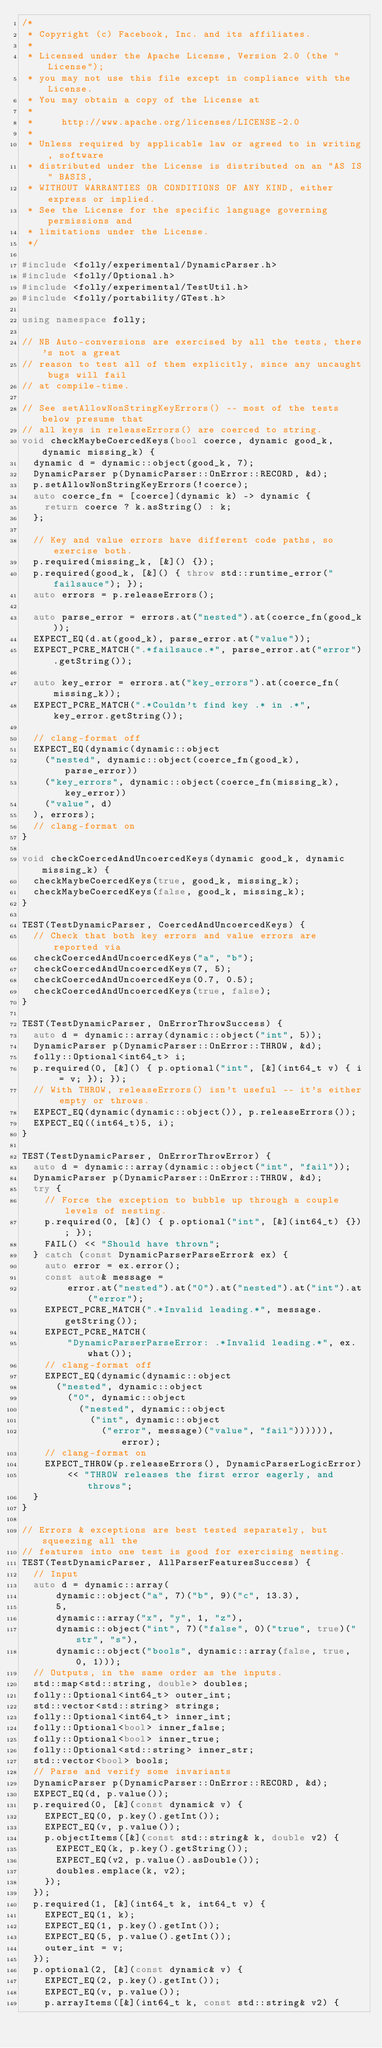<code> <loc_0><loc_0><loc_500><loc_500><_C++_>/*
 * Copyright (c) Facebook, Inc. and its affiliates.
 *
 * Licensed under the Apache License, Version 2.0 (the "License");
 * you may not use this file except in compliance with the License.
 * You may obtain a copy of the License at
 *
 *     http://www.apache.org/licenses/LICENSE-2.0
 *
 * Unless required by applicable law or agreed to in writing, software
 * distributed under the License is distributed on an "AS IS" BASIS,
 * WITHOUT WARRANTIES OR CONDITIONS OF ANY KIND, either express or implied.
 * See the License for the specific language governing permissions and
 * limitations under the License.
 */

#include <folly/experimental/DynamicParser.h>
#include <folly/Optional.h>
#include <folly/experimental/TestUtil.h>
#include <folly/portability/GTest.h>

using namespace folly;

// NB Auto-conversions are exercised by all the tests, there's not a great
// reason to test all of them explicitly, since any uncaught bugs will fail
// at compile-time.

// See setAllowNonStringKeyErrors() -- most of the tests below presume that
// all keys in releaseErrors() are coerced to string.
void checkMaybeCoercedKeys(bool coerce, dynamic good_k, dynamic missing_k) {
  dynamic d = dynamic::object(good_k, 7);
  DynamicParser p(DynamicParser::OnError::RECORD, &d);
  p.setAllowNonStringKeyErrors(!coerce);
  auto coerce_fn = [coerce](dynamic k) -> dynamic {
    return coerce ? k.asString() : k;
  };

  // Key and value errors have different code paths, so exercise both.
  p.required(missing_k, [&]() {});
  p.required(good_k, [&]() { throw std::runtime_error("failsauce"); });
  auto errors = p.releaseErrors();

  auto parse_error = errors.at("nested").at(coerce_fn(good_k));
  EXPECT_EQ(d.at(good_k), parse_error.at("value"));
  EXPECT_PCRE_MATCH(".*failsauce.*", parse_error.at("error").getString());

  auto key_error = errors.at("key_errors").at(coerce_fn(missing_k));
  EXPECT_PCRE_MATCH(".*Couldn't find key .* in .*", key_error.getString());

  // clang-format off
  EXPECT_EQ(dynamic(dynamic::object
    ("nested", dynamic::object(coerce_fn(good_k), parse_error))
    ("key_errors", dynamic::object(coerce_fn(missing_k), key_error))
    ("value", d)
  ), errors);
  // clang-format on
}

void checkCoercedAndUncoercedKeys(dynamic good_k, dynamic missing_k) {
  checkMaybeCoercedKeys(true, good_k, missing_k);
  checkMaybeCoercedKeys(false, good_k, missing_k);
}

TEST(TestDynamicParser, CoercedAndUncoercedKeys) {
  // Check that both key errors and value errors are reported via
  checkCoercedAndUncoercedKeys("a", "b");
  checkCoercedAndUncoercedKeys(7, 5);
  checkCoercedAndUncoercedKeys(0.7, 0.5);
  checkCoercedAndUncoercedKeys(true, false);
}

TEST(TestDynamicParser, OnErrorThrowSuccess) {
  auto d = dynamic::array(dynamic::object("int", 5));
  DynamicParser p(DynamicParser::OnError::THROW, &d);
  folly::Optional<int64_t> i;
  p.required(0, [&]() { p.optional("int", [&](int64_t v) { i = v; }); });
  // With THROW, releaseErrors() isn't useful -- it's either empty or throws.
  EXPECT_EQ(dynamic(dynamic::object()), p.releaseErrors());
  EXPECT_EQ((int64_t)5, i);
}

TEST(TestDynamicParser, OnErrorThrowError) {
  auto d = dynamic::array(dynamic::object("int", "fail"));
  DynamicParser p(DynamicParser::OnError::THROW, &d);
  try {
    // Force the exception to bubble up through a couple levels of nesting.
    p.required(0, [&]() { p.optional("int", [&](int64_t) {}); });
    FAIL() << "Should have thrown";
  } catch (const DynamicParserParseError& ex) {
    auto error = ex.error();
    const auto& message =
        error.at("nested").at("0").at("nested").at("int").at("error");
    EXPECT_PCRE_MATCH(".*Invalid leading.*", message.getString());
    EXPECT_PCRE_MATCH(
        "DynamicParserParseError: .*Invalid leading.*", ex.what());
    // clang-format off
    EXPECT_EQ(dynamic(dynamic::object
      ("nested", dynamic::object
        ("0", dynamic::object
          ("nested", dynamic::object
            ("int", dynamic::object
              ("error", message)("value", "fail")))))), error);
    // clang-format on
    EXPECT_THROW(p.releaseErrors(), DynamicParserLogicError)
        << "THROW releases the first error eagerly, and throws";
  }
}

// Errors & exceptions are best tested separately, but squeezing all the
// features into one test is good for exercising nesting.
TEST(TestDynamicParser, AllParserFeaturesSuccess) {
  // Input
  auto d = dynamic::array(
      dynamic::object("a", 7)("b", 9)("c", 13.3),
      5,
      dynamic::array("x", "y", 1, "z"),
      dynamic::object("int", 7)("false", 0)("true", true)("str", "s"),
      dynamic::object("bools", dynamic::array(false, true, 0, 1)));
  // Outputs, in the same order as the inputs.
  std::map<std::string, double> doubles;
  folly::Optional<int64_t> outer_int;
  std::vector<std::string> strings;
  folly::Optional<int64_t> inner_int;
  folly::Optional<bool> inner_false;
  folly::Optional<bool> inner_true;
  folly::Optional<std::string> inner_str;
  std::vector<bool> bools;
  // Parse and verify some invariants
  DynamicParser p(DynamicParser::OnError::RECORD, &d);
  EXPECT_EQ(d, p.value());
  p.required(0, [&](const dynamic& v) {
    EXPECT_EQ(0, p.key().getInt());
    EXPECT_EQ(v, p.value());
    p.objectItems([&](const std::string& k, double v2) {
      EXPECT_EQ(k, p.key().getString());
      EXPECT_EQ(v2, p.value().asDouble());
      doubles.emplace(k, v2);
    });
  });
  p.required(1, [&](int64_t k, int64_t v) {
    EXPECT_EQ(1, k);
    EXPECT_EQ(1, p.key().getInt());
    EXPECT_EQ(5, p.value().getInt());
    outer_int = v;
  });
  p.optional(2, [&](const dynamic& v) {
    EXPECT_EQ(2, p.key().getInt());
    EXPECT_EQ(v, p.value());
    p.arrayItems([&](int64_t k, const std::string& v2) {</code> 